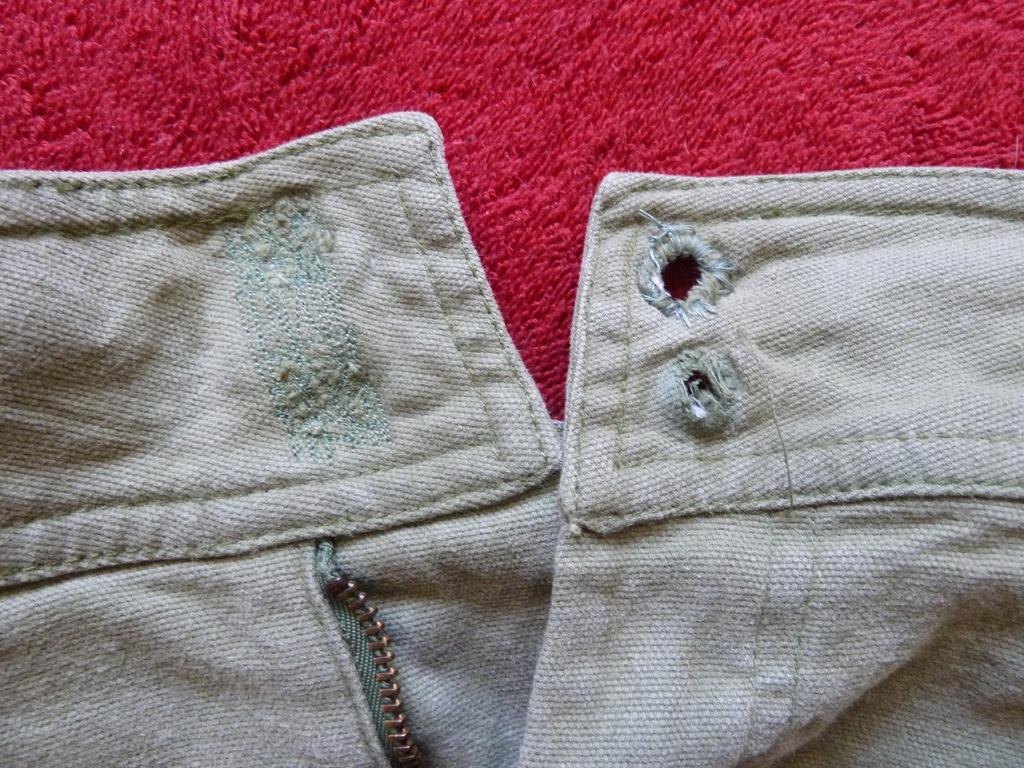What type of clothing item is featured in the image? There is a jeans and zip in the image. What color are the jeans and zip? The jeans and zip are white in color. What other color is present in the image? There is a red color cloth in the image. How many mittens can be seen in the image? There are no mittens present in the image. Is there a turkey sitting on the desk in the image? There is no desk or turkey present in the image. 